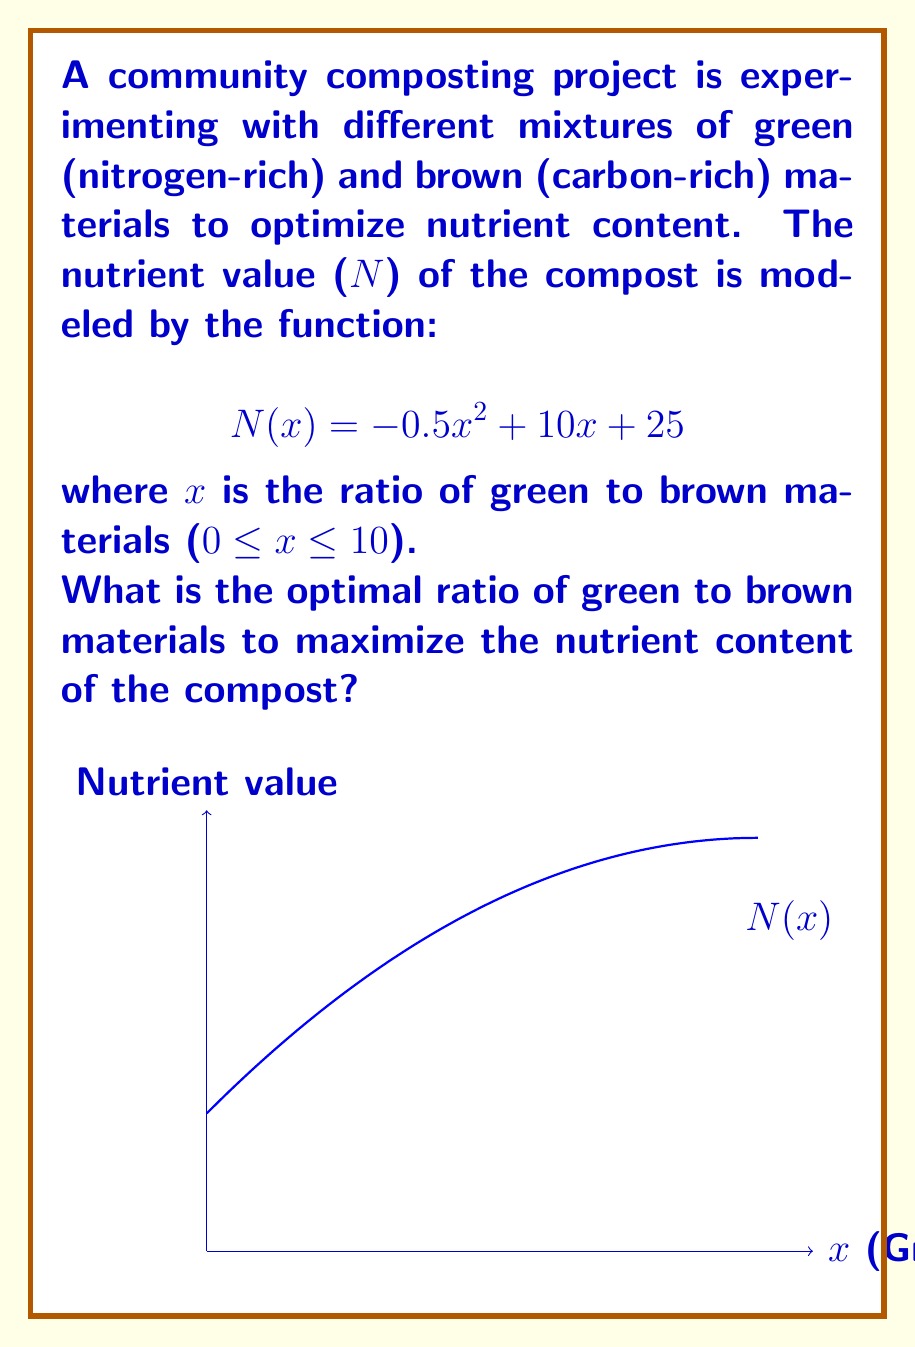Could you help me with this problem? To find the optimal ratio, we need to determine the maximum point of the quadratic function $N(x) = -0.5x^2 + 10x + 25$.

Step 1: Find the derivative of N(x).
$$N'(x) = -x + 10$$

Step 2: Set the derivative equal to zero and solve for x.
$$-x + 10 = 0$$
$$x = 10$$

Step 3: Verify this is a maximum by checking the second derivative.
$$N''(x) = -1$$
Since $N''(x)$ is negative, the critical point is a maximum.

Step 4: Check the domain constraints (0 ≤ x ≤ 10).
The solution x = 10 is within the given domain.

Therefore, the optimal ratio of green to brown materials is 10:1.
Answer: 10:1 